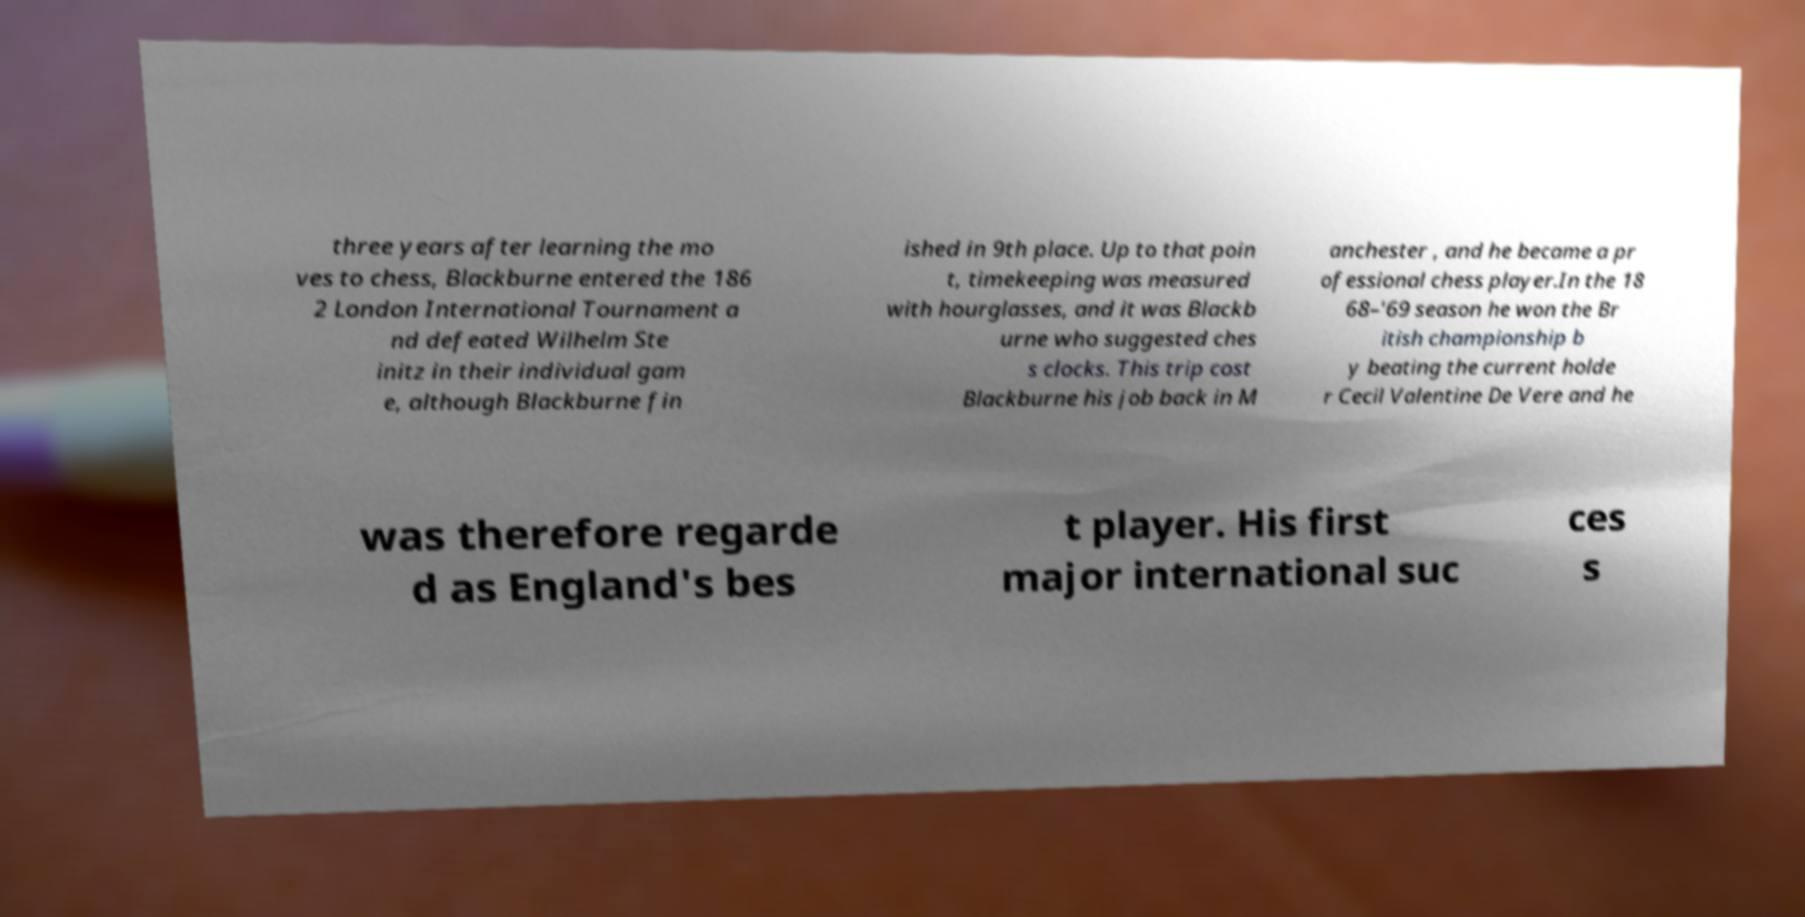For documentation purposes, I need the text within this image transcribed. Could you provide that? three years after learning the mo ves to chess, Blackburne entered the 186 2 London International Tournament a nd defeated Wilhelm Ste initz in their individual gam e, although Blackburne fin ished in 9th place. Up to that poin t, timekeeping was measured with hourglasses, and it was Blackb urne who suggested ches s clocks. This trip cost Blackburne his job back in M anchester , and he became a pr ofessional chess player.In the 18 68–'69 season he won the Br itish championship b y beating the current holde r Cecil Valentine De Vere and he was therefore regarde d as England's bes t player. His first major international suc ces s 